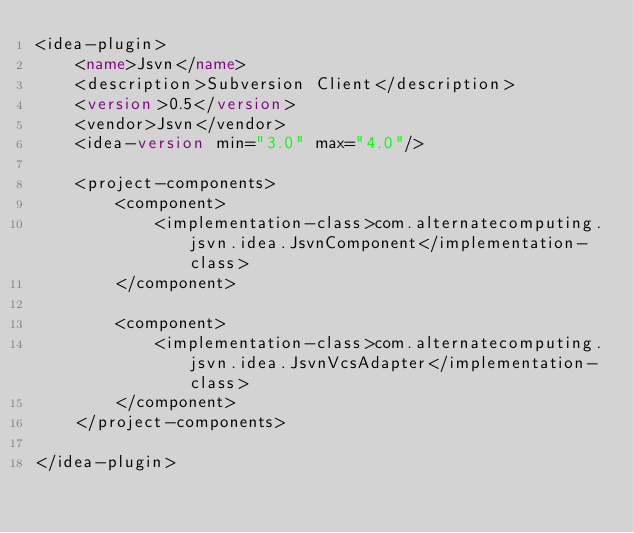Convert code to text. <code><loc_0><loc_0><loc_500><loc_500><_XML_><idea-plugin>
    <name>Jsvn</name>
    <description>Subversion Client</description>
    <version>0.5</version>
    <vendor>Jsvn</vendor>
    <idea-version min="3.0" max="4.0"/>

    <project-components>
        <component>
            <implementation-class>com.alternatecomputing.jsvn.idea.JsvnComponent</implementation-class>
        </component>

        <component>
            <implementation-class>com.alternatecomputing.jsvn.idea.JsvnVcsAdapter</implementation-class>
        </component>
    </project-components>

</idea-plugin>
</code> 